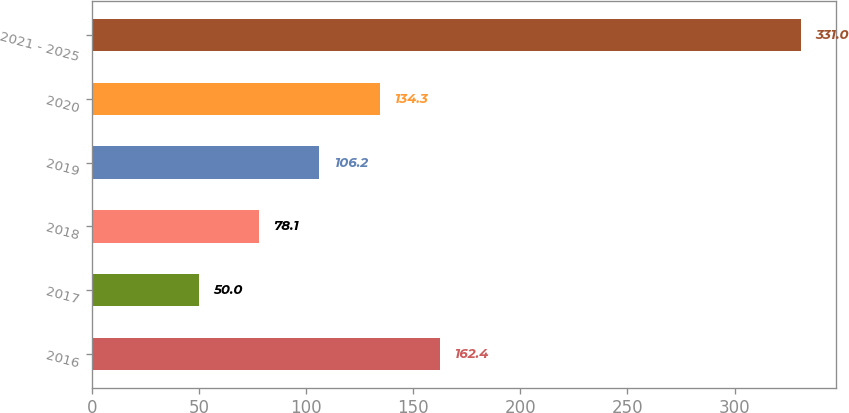<chart> <loc_0><loc_0><loc_500><loc_500><bar_chart><fcel>2016<fcel>2017<fcel>2018<fcel>2019<fcel>2020<fcel>2021 - 2025<nl><fcel>162.4<fcel>50<fcel>78.1<fcel>106.2<fcel>134.3<fcel>331<nl></chart> 